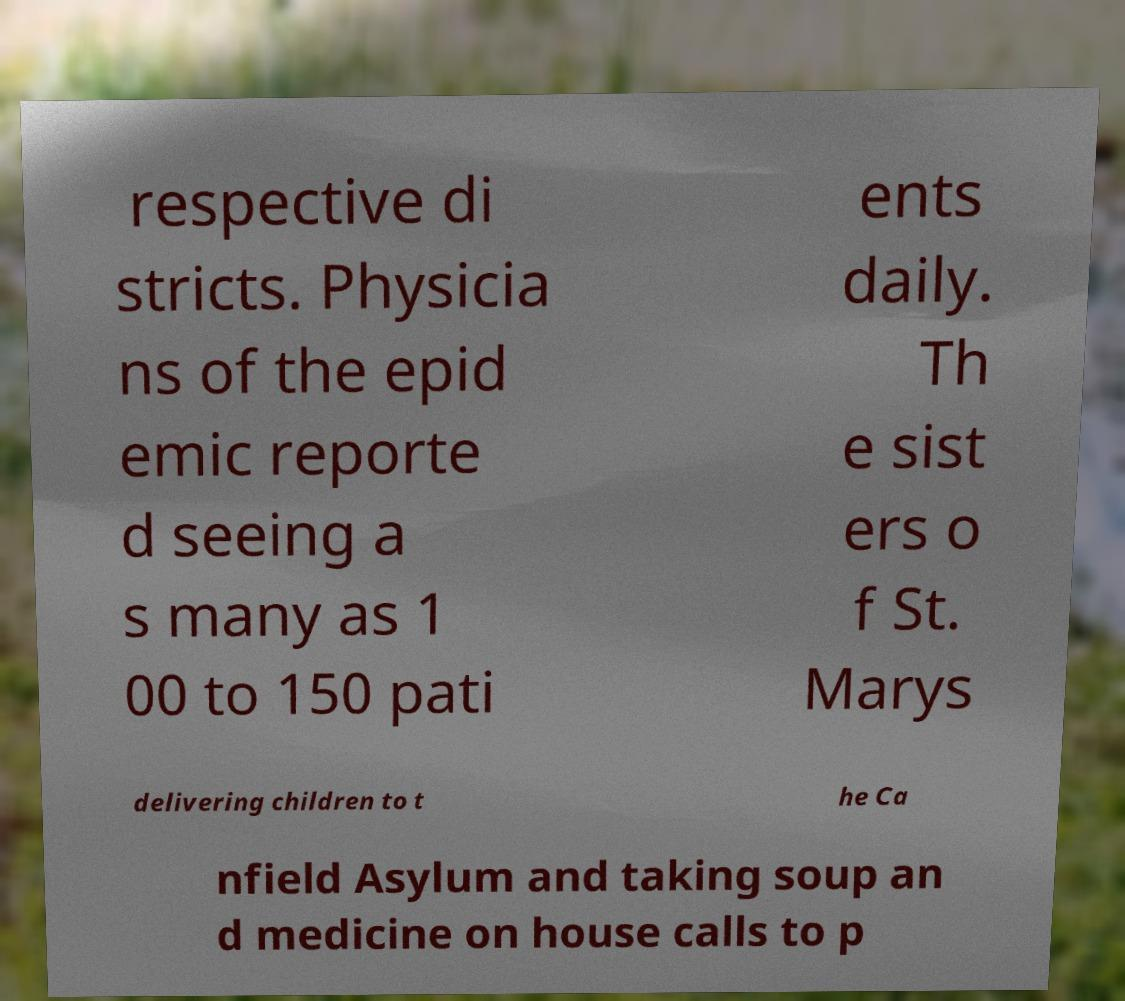Could you extract and type out the text from this image? respective di stricts. Physicia ns of the epid emic reporte d seeing a s many as 1 00 to 150 pati ents daily. Th e sist ers o f St. Marys delivering children to t he Ca nfield Asylum and taking soup an d medicine on house calls to p 